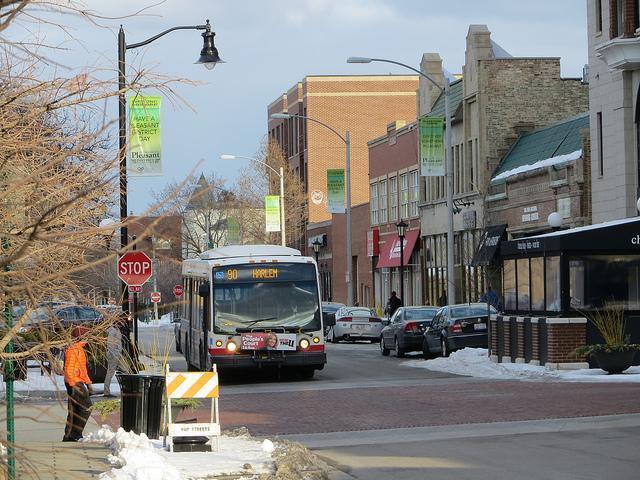How many cars can you see?
Give a very brief answer. 2. 